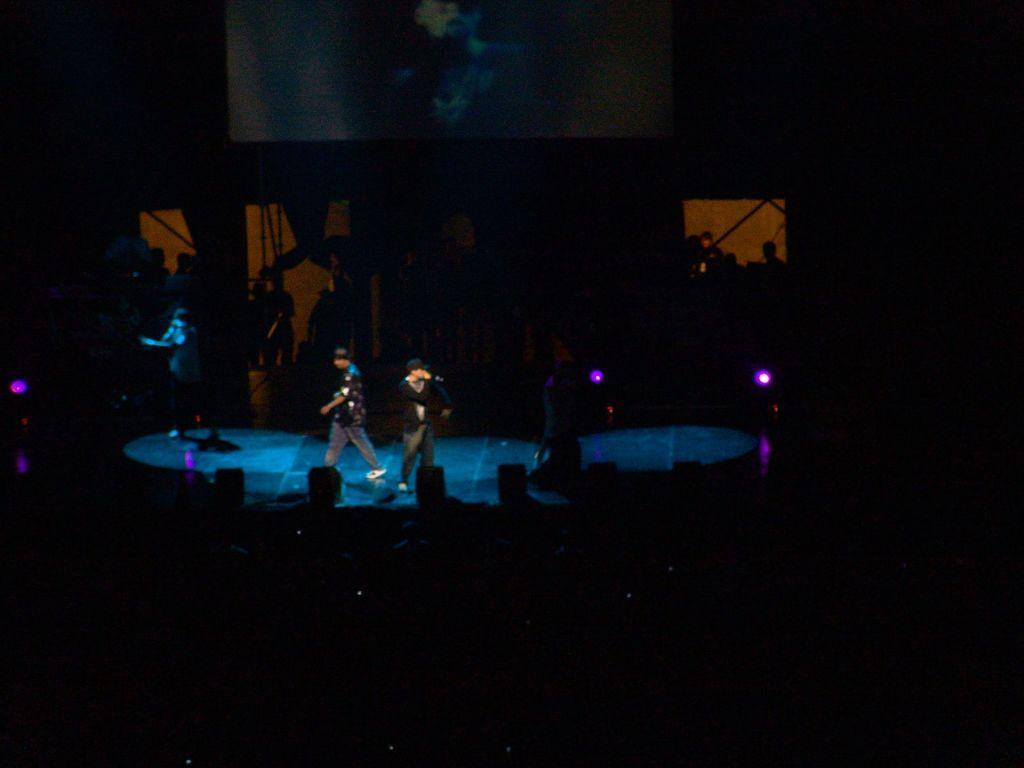Could you give a brief overview of what you see in this image? In this image, in the middle, we can see a man wearing a black color shirt is standing and holding a microphone in his hand. In the middle, we can also see another person walking. On the left side, we can also see a person. In the background, we can see black color, at the bottom, we can see some speakers and black color. In the background, we can also see some lights. 